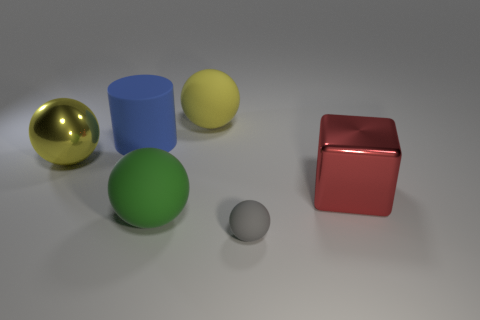What is the color of the cylinder that is the same size as the red thing?
Make the answer very short. Blue. How many rubber things are either tiny gray things or cylinders?
Offer a terse response. 2. How many rubber things are left of the small gray thing and in front of the blue object?
Ensure brevity in your answer.  1. Are there any other things that are the same shape as the blue rubber thing?
Your answer should be very brief. No. How many other objects are the same size as the yellow metal thing?
Provide a short and direct response. 4. Is the size of the metal object behind the red thing the same as the yellow thing that is to the right of the blue cylinder?
Offer a terse response. Yes. What number of objects are large rubber objects or large objects that are to the right of the big blue matte object?
Ensure brevity in your answer.  4. How big is the metallic thing right of the blue matte thing?
Give a very brief answer. Large. Is the number of large blue cylinders left of the big blue rubber cylinder less than the number of large cylinders that are on the right side of the big yellow metal thing?
Your response must be concise. Yes. There is a ball that is both on the right side of the big green matte object and in front of the big blue matte thing; what material is it?
Give a very brief answer. Rubber. 